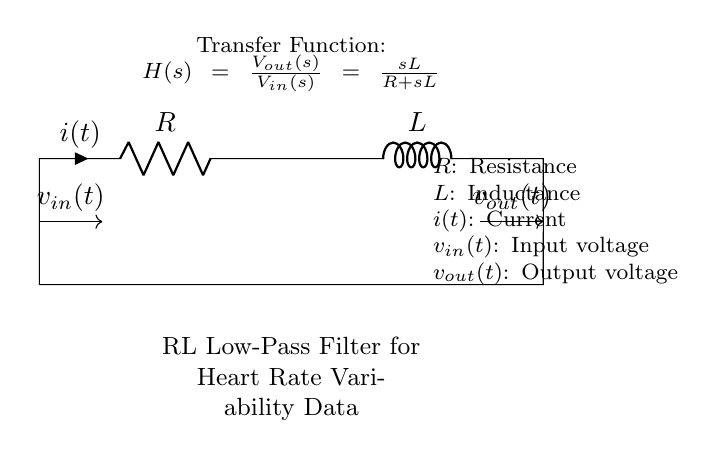What type of filter is represented in this circuit? This circuit represents a low-pass filter, as indicated by the label "RL Low-Pass Filter" in the diagram. A low-pass filter allows low-frequency signals to pass through while attenuating higher-frequency signals.
Answer: low-pass filter What are the components used in this circuit? The circuit consists of two main components: a resistor, labeled R, and an inductor, labeled L. These components are essential in the functionality of the RL filter.
Answer: resistor and inductor What is the input voltage of the circuit? The input voltage is represented by the label "v_in(t)," which is shown entering the circuit from the left side, indicating that it is the voltage applied to the circuit.
Answer: v_in(t) What is the transfer function of this circuit? The transfer function, which describes the relationship between the output voltage and input voltage in the circuit, is given as "H(s) = V_out(s)/V_in(s) = sL/(R + sL)" as stated in the diagram.
Answer: H(s) = sL/(R + sL) How does increasing the resistance affect the filter's performance? Increasing the resistance R in a low-pass RL filter decreases the cutoff frequency, meaning that higher frequency signals will be attenuated more, affecting the overall frequency response of the filter. The interaction between resistance and inductance defines how the filter responds to different frequencies.
Answer: decreases cutoff frequency What is the symbol representing the current in the circuit? The symbol representing the current is "i(t)," which is shown on the right side of the resistor, indicating the direction of current flow through the circuit.
Answer: i(t) What is the output voltage of the circuit? The output voltage is indicated by "v_out(t)," which is the voltage taken from the output of the circuit after the signal has passed through the filter.
Answer: v_out(t) 